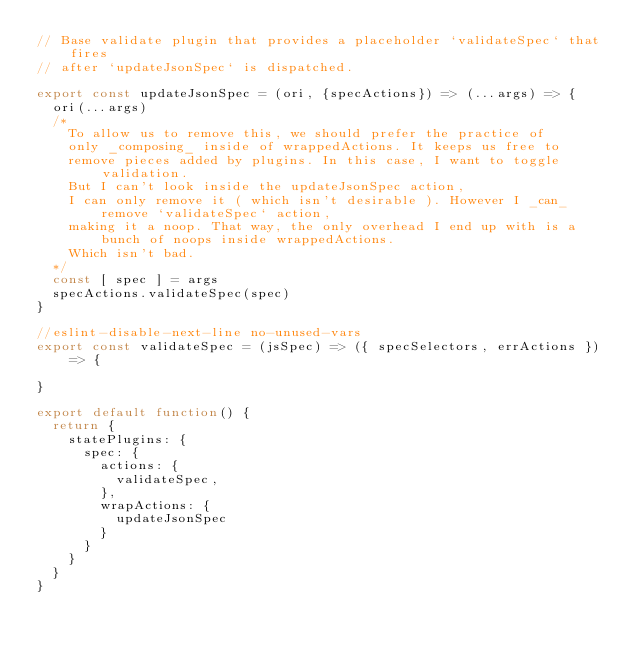<code> <loc_0><loc_0><loc_500><loc_500><_JavaScript_>// Base validate plugin that provides a placeholder `validateSpec` that fires
// after `updateJsonSpec` is dispatched.

export const updateJsonSpec = (ori, {specActions}) => (...args) => {
  ori(...args)
  /*
    To allow us to remove this, we should prefer the practice of
    only _composing_ inside of wrappedActions. It keeps us free to
    remove pieces added by plugins. In this case, I want to toggle validation.
    But I can't look inside the updateJsonSpec action,
    I can only remove it ( which isn't desirable ). However I _can_ remove `validateSpec` action,
    making it a noop. That way, the only overhead I end up with is a bunch of noops inside wrappedActions.
    Which isn't bad.
  */
  const [ spec ] = args
  specActions.validateSpec(spec)
}

//eslint-disable-next-line no-unused-vars
export const validateSpec = (jsSpec) => ({ specSelectors, errActions }) => {

}

export default function() {
  return {
    statePlugins: {
      spec: {
        actions: {
          validateSpec,
        },
        wrapActions: {
          updateJsonSpec
        }
      }
    }
  }
}
</code> 